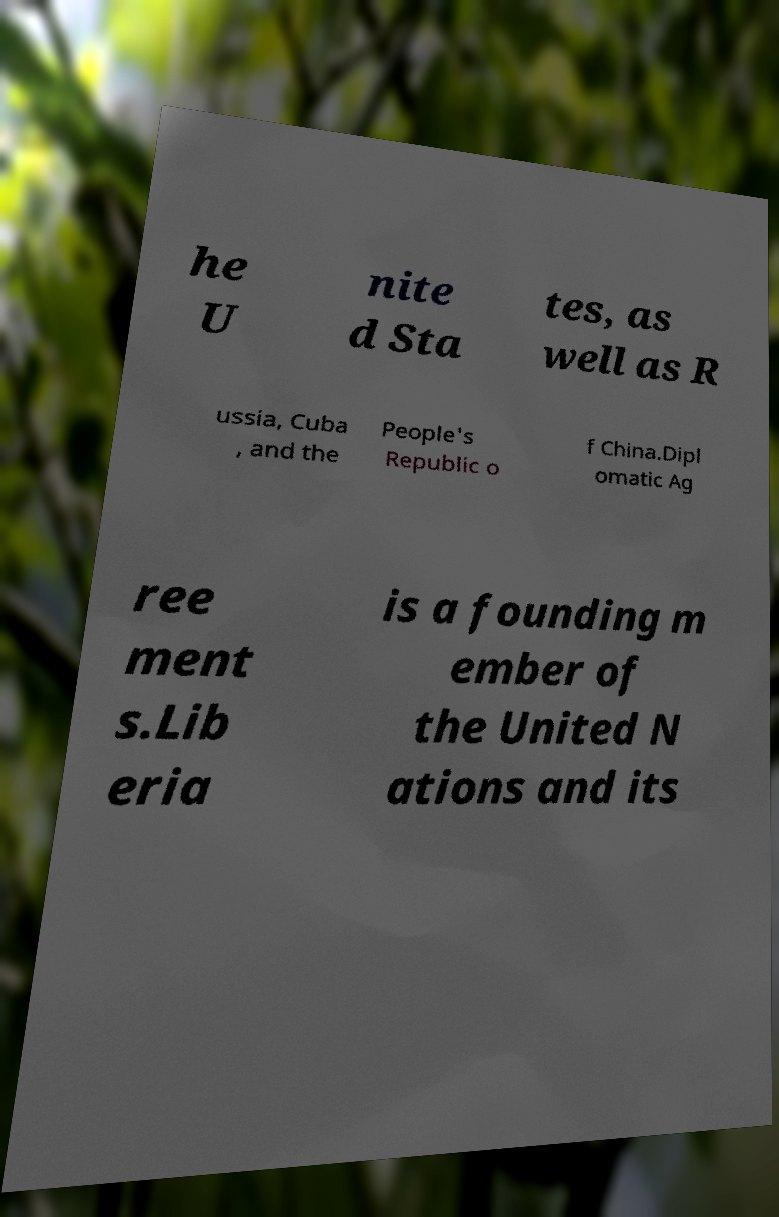Please read and relay the text visible in this image. What does it say? he U nite d Sta tes, as well as R ussia, Cuba , and the People's Republic o f China.Dipl omatic Ag ree ment s.Lib eria is a founding m ember of the United N ations and its 